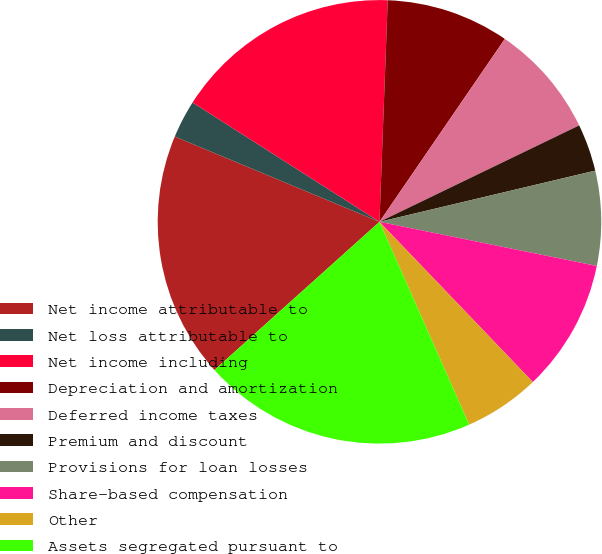Convert chart. <chart><loc_0><loc_0><loc_500><loc_500><pie_chart><fcel>Net income attributable to<fcel>Net loss attributable to<fcel>Net income including<fcel>Depreciation and amortization<fcel>Deferred income taxes<fcel>Premium and discount<fcel>Provisions for loan losses<fcel>Share-based compensation<fcel>Other<fcel>Assets segregated pursuant to<nl><fcel>17.93%<fcel>2.76%<fcel>16.55%<fcel>8.97%<fcel>8.28%<fcel>3.45%<fcel>6.9%<fcel>9.66%<fcel>5.52%<fcel>19.99%<nl></chart> 